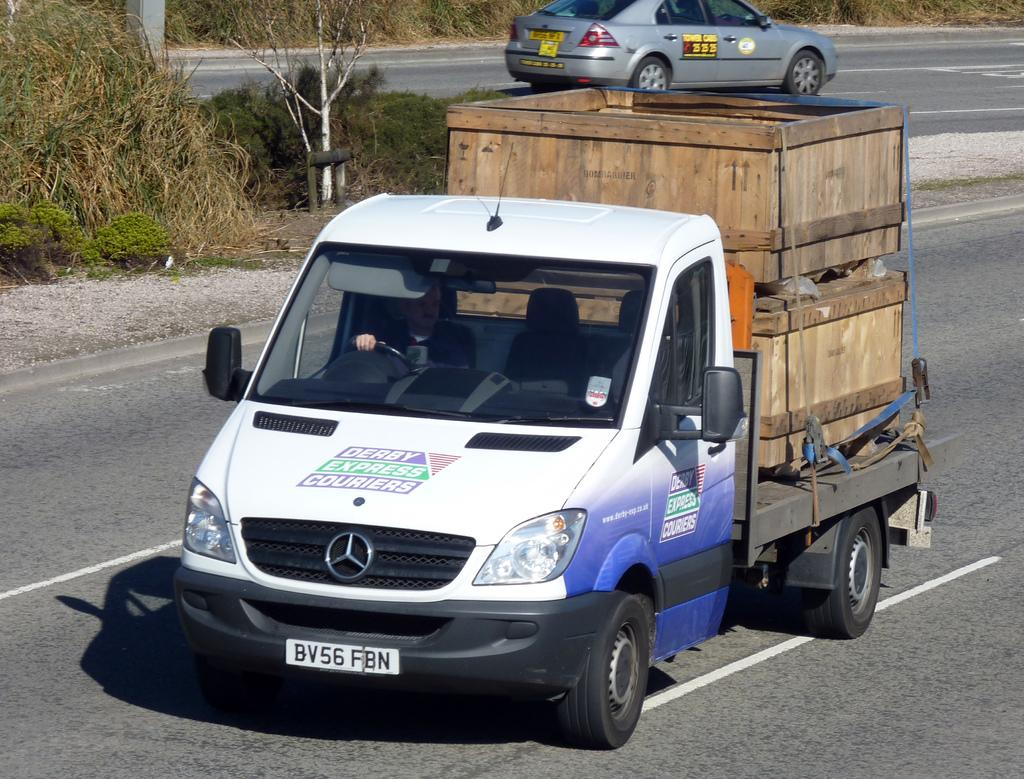<image>
Describe the image concisely. Mercedes Benz truck carrying a bunch of wooden crates on the back for transport, the license plate says: BV56 FBN. 